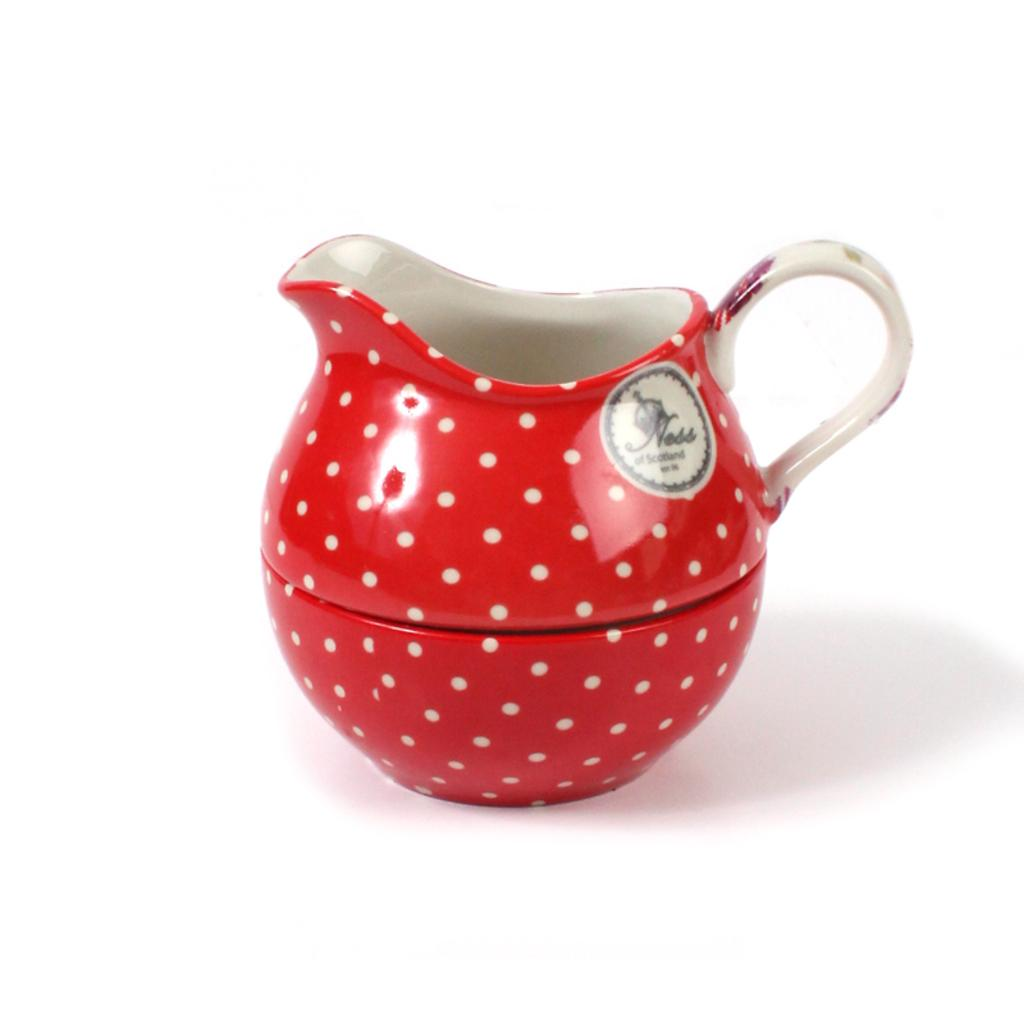What is the main object in the image? There is a jug in the image. Can you describe the position of the jug? The jug is on an object. What type of comfort can be seen in the image? There is no indication of comfort in the image; it only features a jug on an object. 